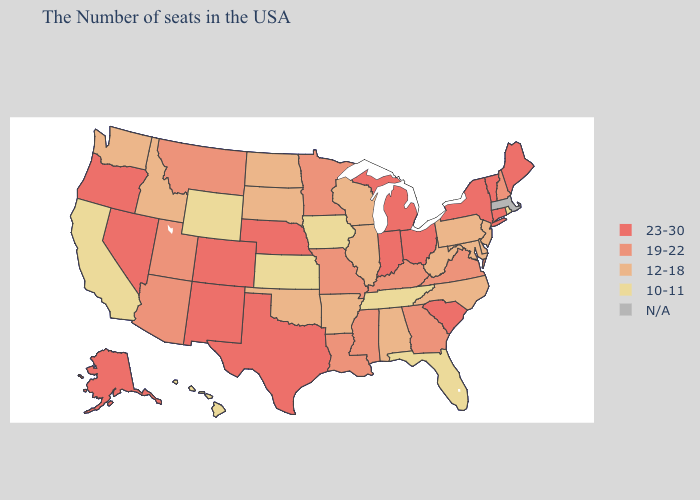What is the highest value in states that border Washington?
Answer briefly. 23-30. Does North Carolina have the highest value in the South?
Keep it brief. No. What is the highest value in states that border Massachusetts?
Answer briefly. 23-30. Does Iowa have the lowest value in the USA?
Give a very brief answer. Yes. What is the value of Oregon?
Write a very short answer. 23-30. Which states hav the highest value in the MidWest?
Concise answer only. Ohio, Michigan, Indiana, Nebraska. Name the states that have a value in the range 12-18?
Give a very brief answer. New Jersey, Delaware, Maryland, Pennsylvania, North Carolina, West Virginia, Alabama, Wisconsin, Illinois, Arkansas, Oklahoma, South Dakota, North Dakota, Idaho, Washington. What is the value of Virginia?
Concise answer only. 19-22. How many symbols are there in the legend?
Short answer required. 5. Does New York have the highest value in the USA?
Write a very short answer. Yes. Among the states that border Oklahoma , which have the highest value?
Answer briefly. Texas, Colorado, New Mexico. What is the value of South Carolina?
Give a very brief answer. 23-30. Does the map have missing data?
Quick response, please. Yes. Does the first symbol in the legend represent the smallest category?
Write a very short answer. No. Does Texas have the highest value in the USA?
Keep it brief. Yes. 